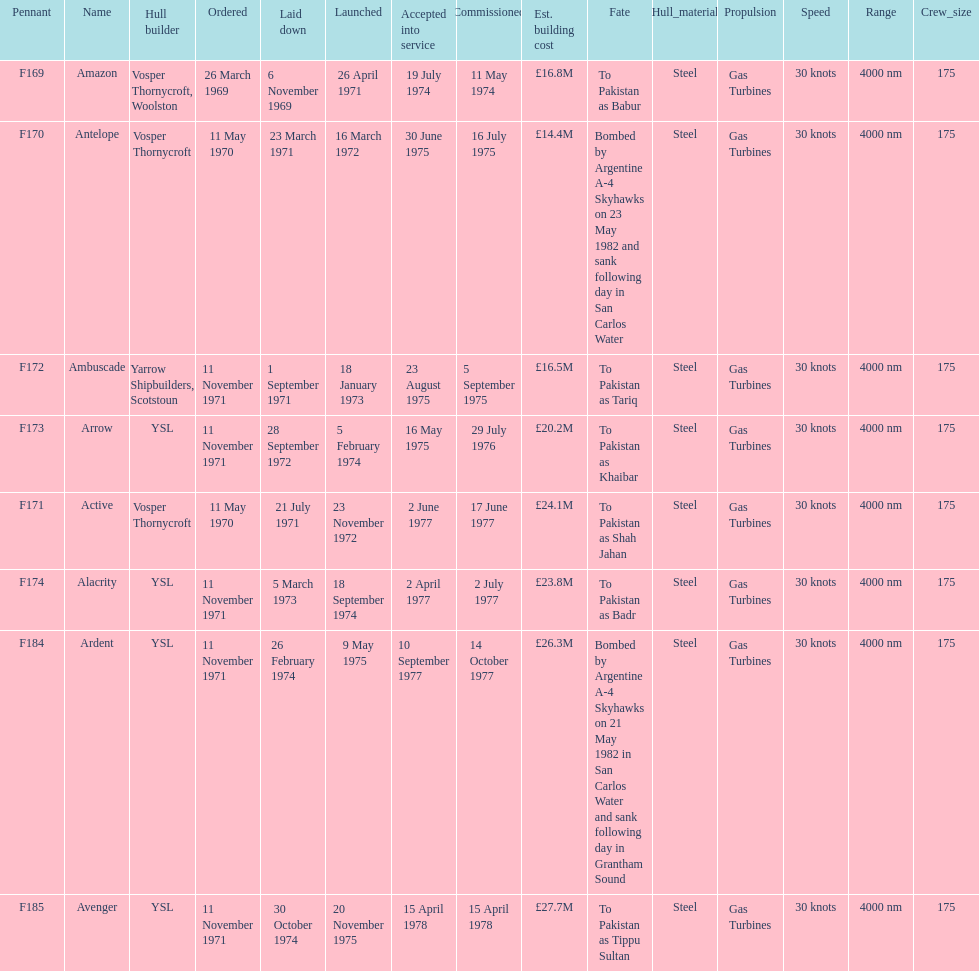What is the last name listed on this chart? Avenger. 